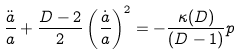Convert formula to latex. <formula><loc_0><loc_0><loc_500><loc_500>\frac { \ddot { a } } { a } + \frac { D - 2 } { 2 } \left ( \frac { \dot { a } } { a } \right ) ^ { 2 } = - \frac { \kappa ( D ) } { ( D - 1 ) } p</formula> 